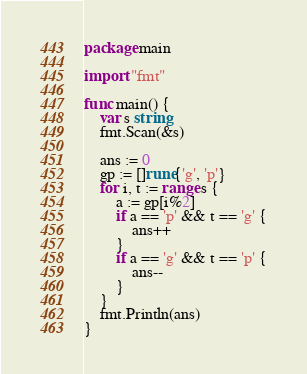Convert code to text. <code><loc_0><loc_0><loc_500><loc_500><_Go_>package main

import "fmt"

func main() {
	var s string
	fmt.Scan(&s)

	ans := 0
	gp := []rune{'g', 'p'}
	for i, t := range s {
		a := gp[i%2]
		if a == 'p' && t == 'g' {
			ans++
		}
		if a == 'g' && t == 'p' {
			ans--
		}
	}
	fmt.Println(ans)
}
</code> 